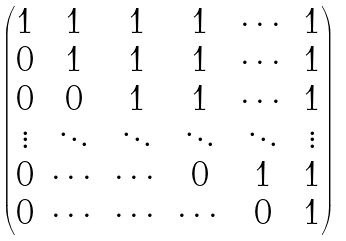Convert formula to latex. <formula><loc_0><loc_0><loc_500><loc_500>\begin{pmatrix} 1 & 1 & 1 & 1 & \cdots & 1 \\ 0 & 1 & 1 & 1 & \cdots & 1 \\ 0 & 0 & 1 & 1 & \cdots & 1 \\ \vdots & \ddots & \ddots & \ddots & \ddots & \vdots \\ 0 & \cdots & \cdots & 0 & 1 & 1 \\ 0 & \cdots & \cdots & \cdots & 0 & 1 \end{pmatrix}</formula> 